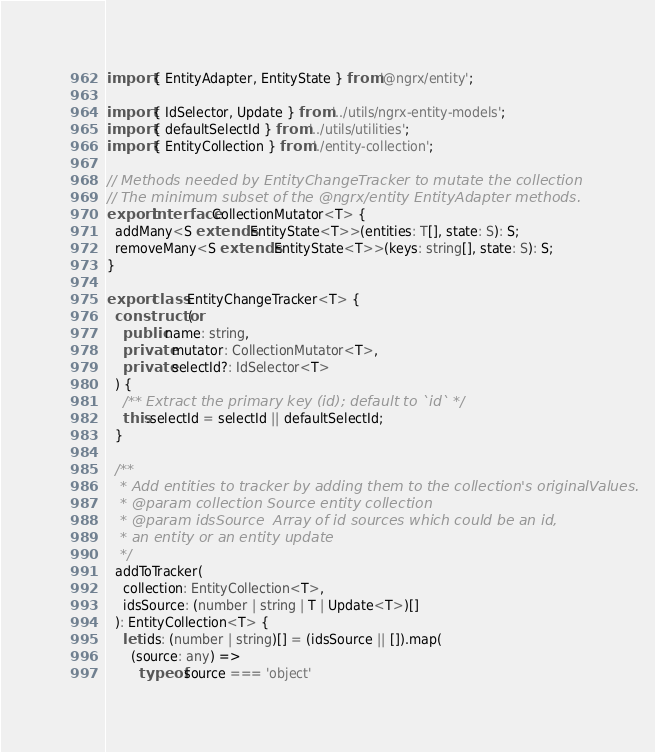Convert code to text. <code><loc_0><loc_0><loc_500><loc_500><_TypeScript_>import { EntityAdapter, EntityState } from '@ngrx/entity';

import { IdSelector, Update } from '../utils/ngrx-entity-models';
import { defaultSelectId } from '../utils/utilities';
import { EntityCollection } from './entity-collection';

// Methods needed by EntityChangeTracker to mutate the collection
// The minimum subset of the @ngrx/entity EntityAdapter methods.
export interface CollectionMutator<T> {
  addMany<S extends EntityState<T>>(entities: T[], state: S): S;
  removeMany<S extends EntityState<T>>(keys: string[], state: S): S;
}

export class EntityChangeTracker<T> {
  constructor(
    public name: string,
    private mutator: CollectionMutator<T>,
    private selectId?: IdSelector<T>
  ) {
    /** Extract the primary key (id); default to `id` */
    this.selectId = selectId || defaultSelectId;
  }

  /**
   * Add entities to tracker by adding them to the collection's originalValues.
   * @param collection Source entity collection
   * @param idsSource  Array of id sources which could be an id,
   * an entity or an entity update
   */
  addToTracker(
    collection: EntityCollection<T>,
    idsSource: (number | string | T | Update<T>)[]
  ): EntityCollection<T> {
    let ids: (number | string)[] = (idsSource || []).map(
      (source: any) =>
        typeof source === 'object'</code> 